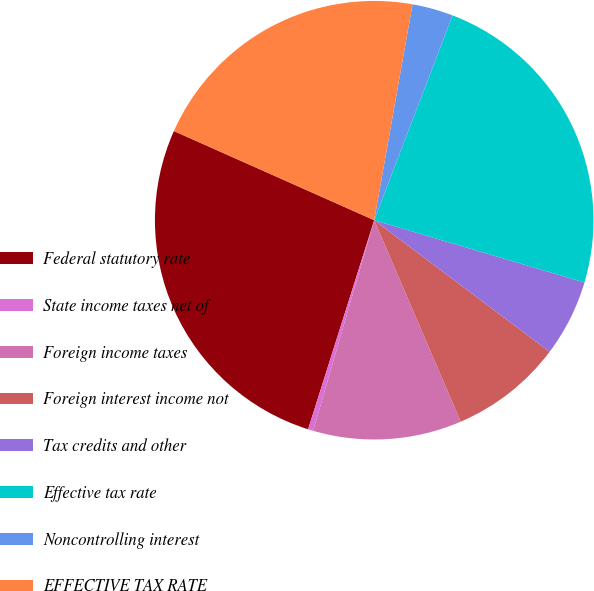Convert chart to OTSL. <chart><loc_0><loc_0><loc_500><loc_500><pie_chart><fcel>Federal statutory rate<fcel>State income taxes net of<fcel>Foreign income taxes<fcel>Foreign interest income not<fcel>Tax credits and other<fcel>Effective tax rate<fcel>Noncontrolling interest<fcel>EFFECTIVE TAX RATE<nl><fcel>26.79%<fcel>0.38%<fcel>10.95%<fcel>8.3%<fcel>5.66%<fcel>23.77%<fcel>3.02%<fcel>21.13%<nl></chart> 